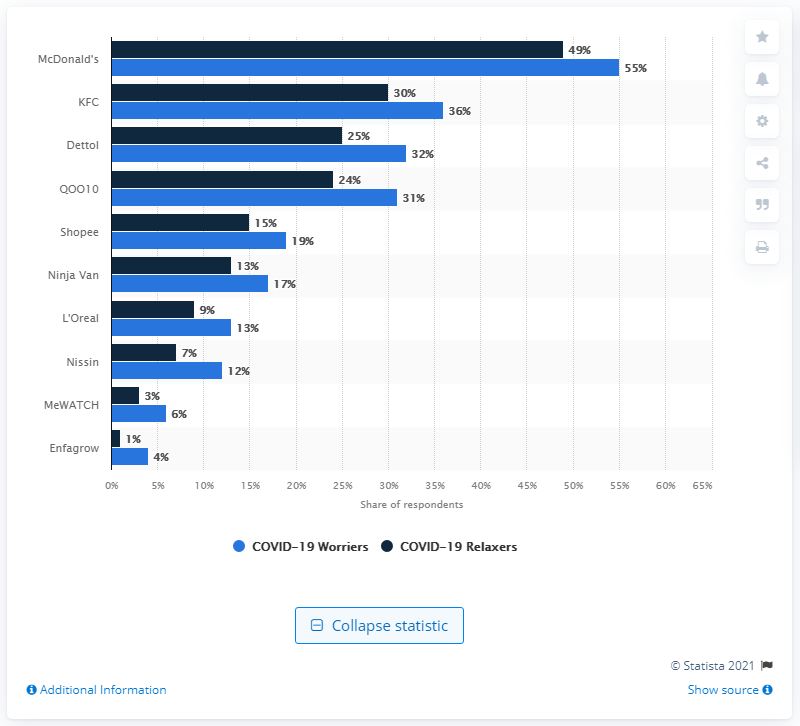Specify some key components in this picture. McDonald's was the brand that was purchased the most by worriers. Dettol is the most popular disinfectant brand in Singapore. The average number of COVID-19 relaxer purchases is 17.6. During the COVID-19 pandemic, McDonald's was the leading brand among consumers in Singapore. 